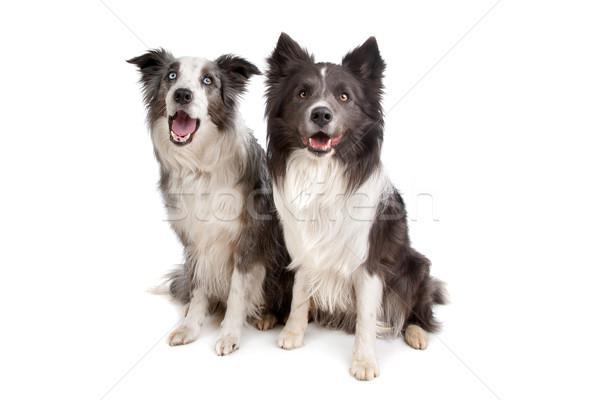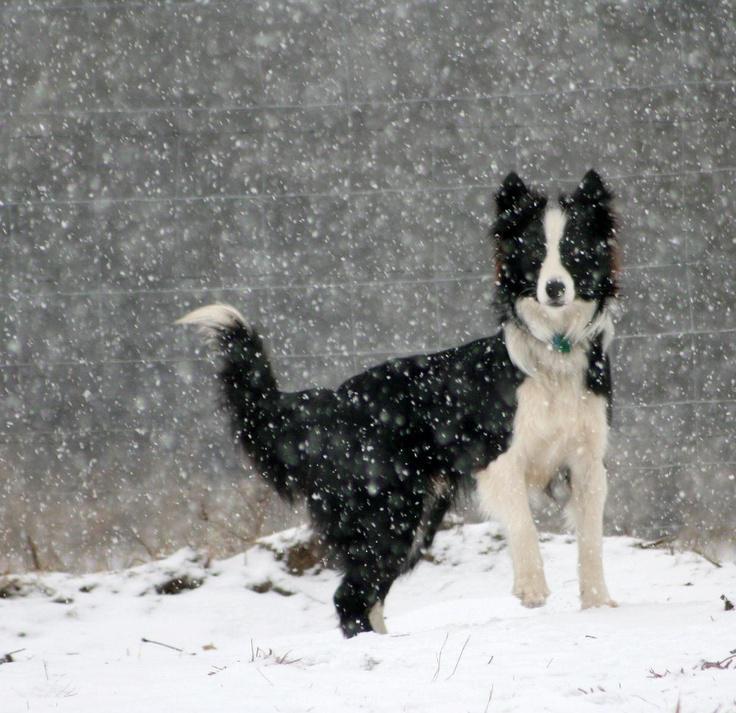The first image is the image on the left, the second image is the image on the right. Analyze the images presented: Is the assertion "There are visible paw prints in the snow in both images." valid? Answer yes or no. No. The first image is the image on the left, the second image is the image on the right. For the images displayed, is the sentence "There are no more than two dogs." factually correct? Answer yes or no. No. 